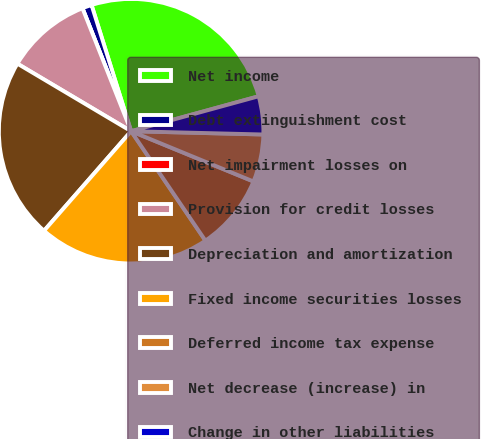Convert chart to OTSL. <chart><loc_0><loc_0><loc_500><loc_500><pie_chart><fcel>Net income<fcel>Debt extinguishment cost<fcel>Net impairment losses on<fcel>Provision for credit losses<fcel>Depreciation and amortization<fcel>Fixed income securities losses<fcel>Deferred income tax expense<fcel>Net decrease (increase) in<fcel>Change in other liabilities<nl><fcel>25.58%<fcel>1.16%<fcel>0.0%<fcel>10.47%<fcel>22.09%<fcel>20.93%<fcel>9.3%<fcel>5.81%<fcel>4.65%<nl></chart> 